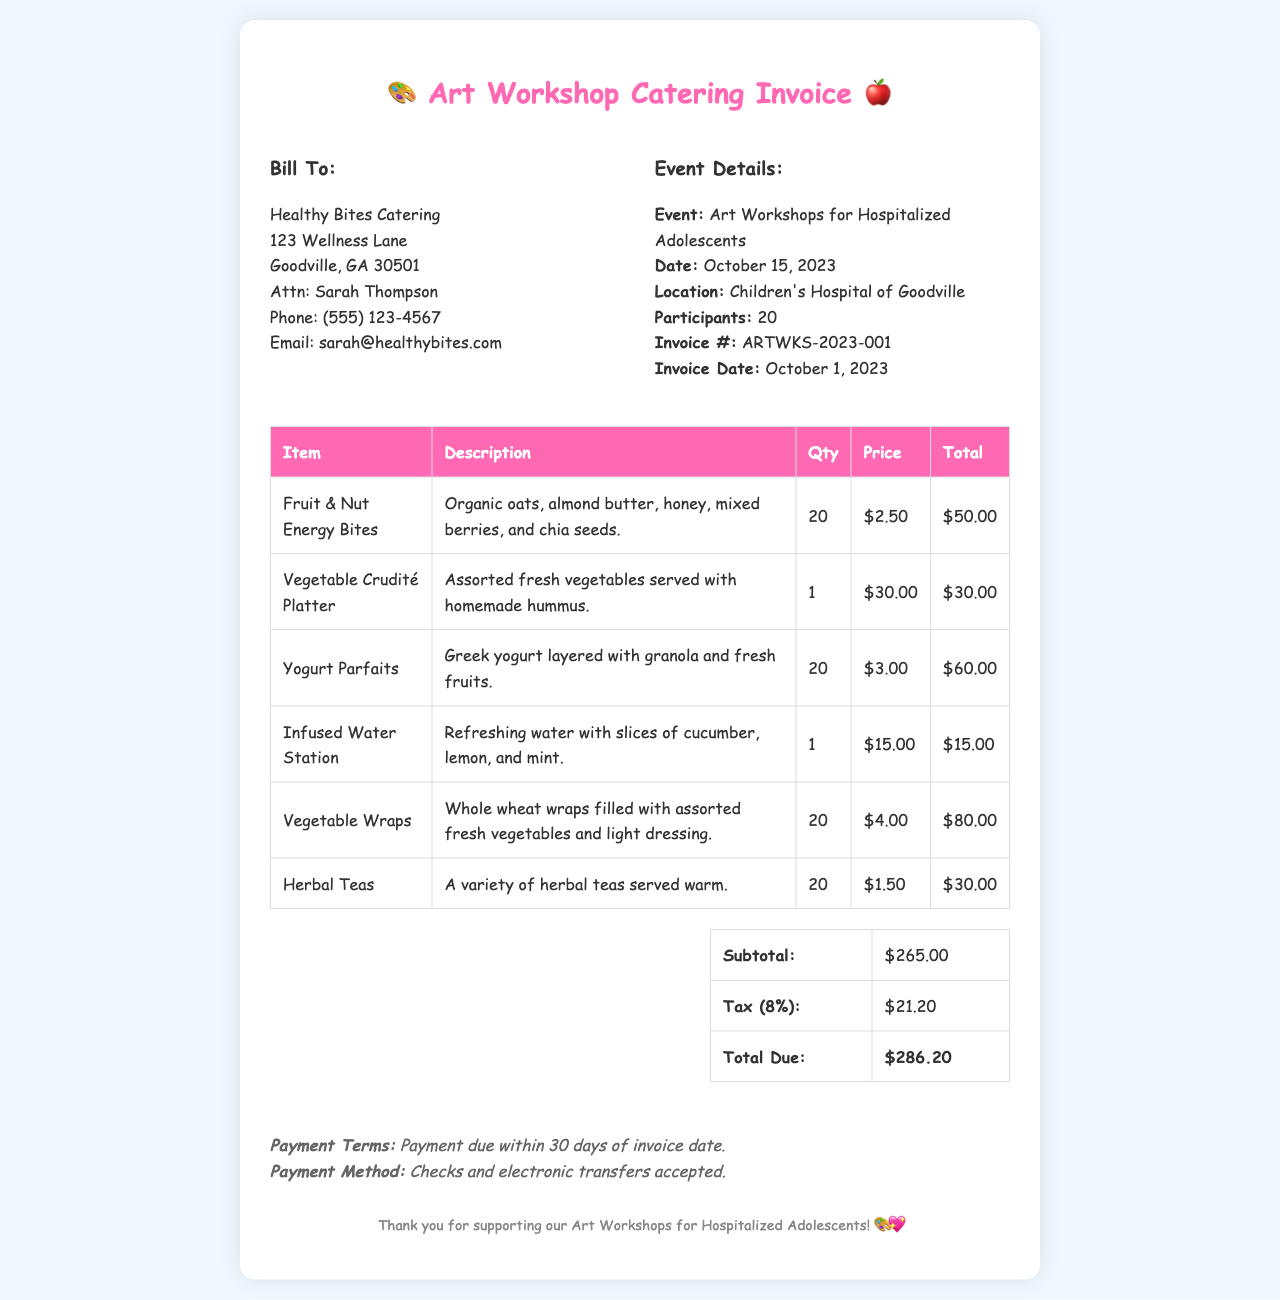What is the invoice number? The invoice number is located in the event details section of the document.
Answer: ARTWKS-2023-001 What is the total due amount? The total due amount is found in the summary table at the bottom of the invoice.
Answer: $286.20 Who is the billing contact? The billing contact's information is listed in the 'Bill To' section of the document.
Answer: Sarah Thompson How many participants are there for the workshops? The number of participants is specified in the event details section of the invoice.
Answer: 20 What item has the highest quantity ordered? To find the highest quantity ordered, we can look at the quantities listed for each item.
Answer: Fruit & Nut Energy Bites What is the subtotal amount before tax? The subtotal is indicated in the summary section prior to the tax calculation.
Answer: $265.00 What type of payment methods are accepted? The accepted payment methods are noted in the payment terms section of the invoice.
Answer: Checks and electronic transfers What is the date of the event? The date of the event is listed in the event details section.
Answer: October 15, 2023 What is the tax percentage applied on the invoice? The tax percentage is mentioned in the summary section, indicating the calculation of tax based on the subtotal.
Answer: 8% 